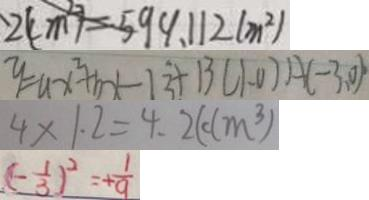<formula> <loc_0><loc_0><loc_500><loc_500>2 ( c m ^ { 2 } ) = 5 9 9 . 1 1 2 ( m ^ { 2 } ) 
 y = a x ^ { 2 } + b x - 1 3 + 1 3 ( 1 - 0 ) A ( - 3 , 0 ) \cdot 
 4 \times 1 . 2 = 4 . 2 ( d m ^ { 3 } ) 
 ( - \frac { 1 } { 3 } ) ^ { 2 } = + \frac { 1 } { 9 }</formula> 